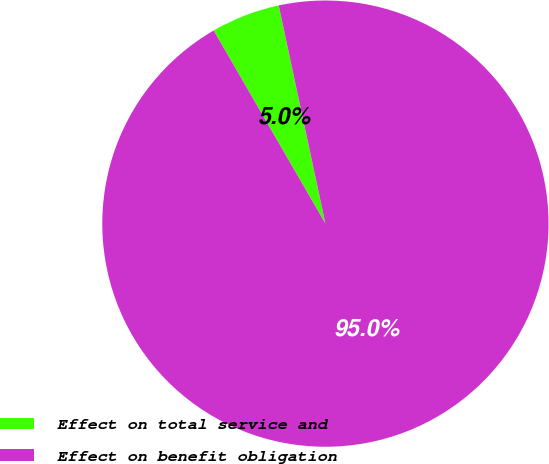<chart> <loc_0><loc_0><loc_500><loc_500><pie_chart><fcel>Effect on total service and<fcel>Effect on benefit obligation<nl><fcel>4.99%<fcel>95.01%<nl></chart> 